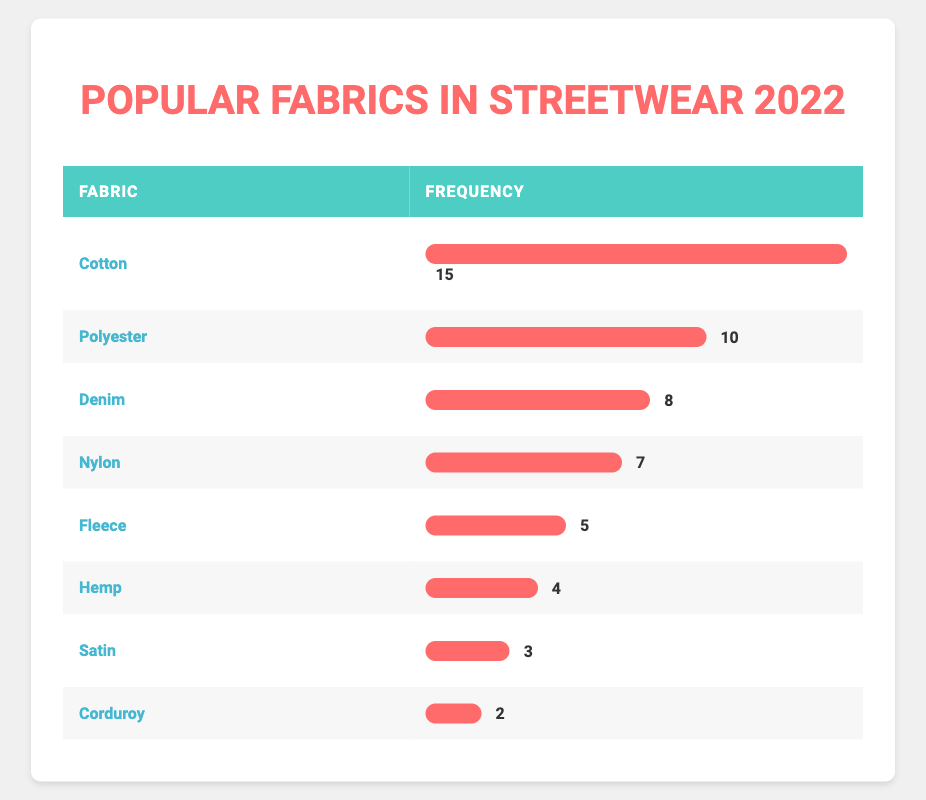What fabric has the highest frequency in streetwear collections for 2022? By examining the table, we can see that "Cotton" has the highest frequency with a value of 15. This is the largest number listed in the frequency column.
Answer: Cotton What is the frequency of denim in streetwear collections for 2022? The table shows the frequency of "Denim" as 8, which is directly stated in the frequency column next to it.
Answer: 8 Is the frequency of hemp higher than that of fleece? By comparing the two frequencies, "Hemp" has a frequency of 4 and "Fleece" has a frequency of 5. Since 4 is less than 5, it is false that hemp's frequency is higher than fleece's.
Answer: No What is the combined frequency of cotton and polyester in streetwear collections for 2022? To find the combined frequency, we add the two values together: Cotton (15) + Polyester (10) = 25. Thus, the total frequency is 25.
Answer: 25 What is the median frequency of the fabrics listed? The frequencies are: 15, 10, 8, 7, 5, 4, 3, 2. When arranged in ascending order, we get 2, 3, 4, 5, 7, 8, 10, 15. There are 8 values, so the median is the average of the 4th and 5th values: (5 + 7) / 2 = 6.
Answer: 6 Which fabric or fabrics have a frequency lower than 5? The table indicates that both "Hemp" (4), "Satin" (3), and "Corduroy" (2) have frequencies lower than 5. Therefore, the answer includes all three fabrics.
Answer: Hemp, Satin, Corduroy What percentage of the total frequency is made up by nylon? First, we sum all the frequencies: 15 + 10 + 8 + 7 + 5 + 4 + 3 + 2 = 54. The frequency of "Nylon" is 7. To find the percentage, we calculate (7 / 54) * 100 ≈ 12.96%.
Answer: Approximately 12.96% Are there more types of fabric with a frequency of 2 or less, or greater than 2? From the table, "Corduroy" is the only fabric with a frequency of 2 and "Satin" has a frequency of 3. Thus, there is 1 fabric with frequency 2 or less and 6 fabrics with frequencies greater than 2 (Cotton, Polyester, Denim, Nylon, Fleece, and Hemp). It shows more fabrics are greater than 2.
Answer: Greater than 2 